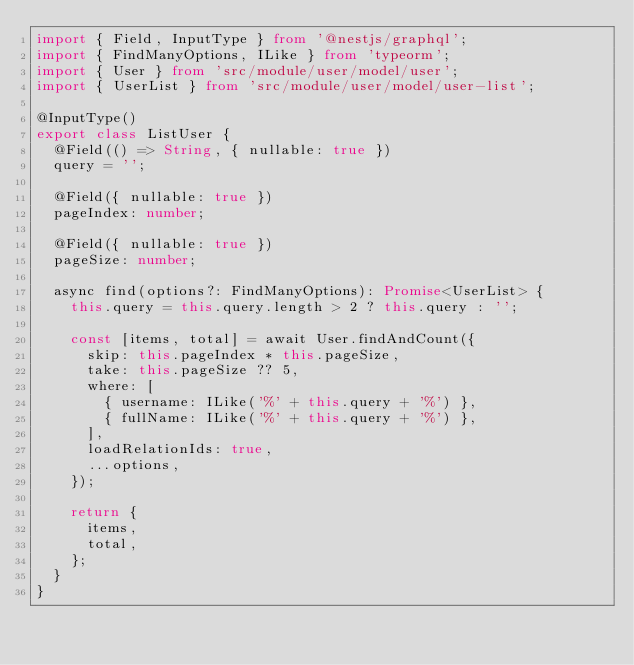<code> <loc_0><loc_0><loc_500><loc_500><_TypeScript_>import { Field, InputType } from '@nestjs/graphql';
import { FindManyOptions, ILike } from 'typeorm';
import { User } from 'src/module/user/model/user';
import { UserList } from 'src/module/user/model/user-list';

@InputType()
export class ListUser {
  @Field(() => String, { nullable: true })
  query = '';

  @Field({ nullable: true })
  pageIndex: number;

  @Field({ nullable: true })
  pageSize: number;

  async find(options?: FindManyOptions): Promise<UserList> {
    this.query = this.query.length > 2 ? this.query : '';

    const [items, total] = await User.findAndCount({
      skip: this.pageIndex * this.pageSize,
      take: this.pageSize ?? 5,
      where: [
        { username: ILike('%' + this.query + '%') },
        { fullName: ILike('%' + this.query + '%') },
      ],
      loadRelationIds: true,
      ...options,
    });

    return {
      items,
      total,
    };
  }
}
</code> 